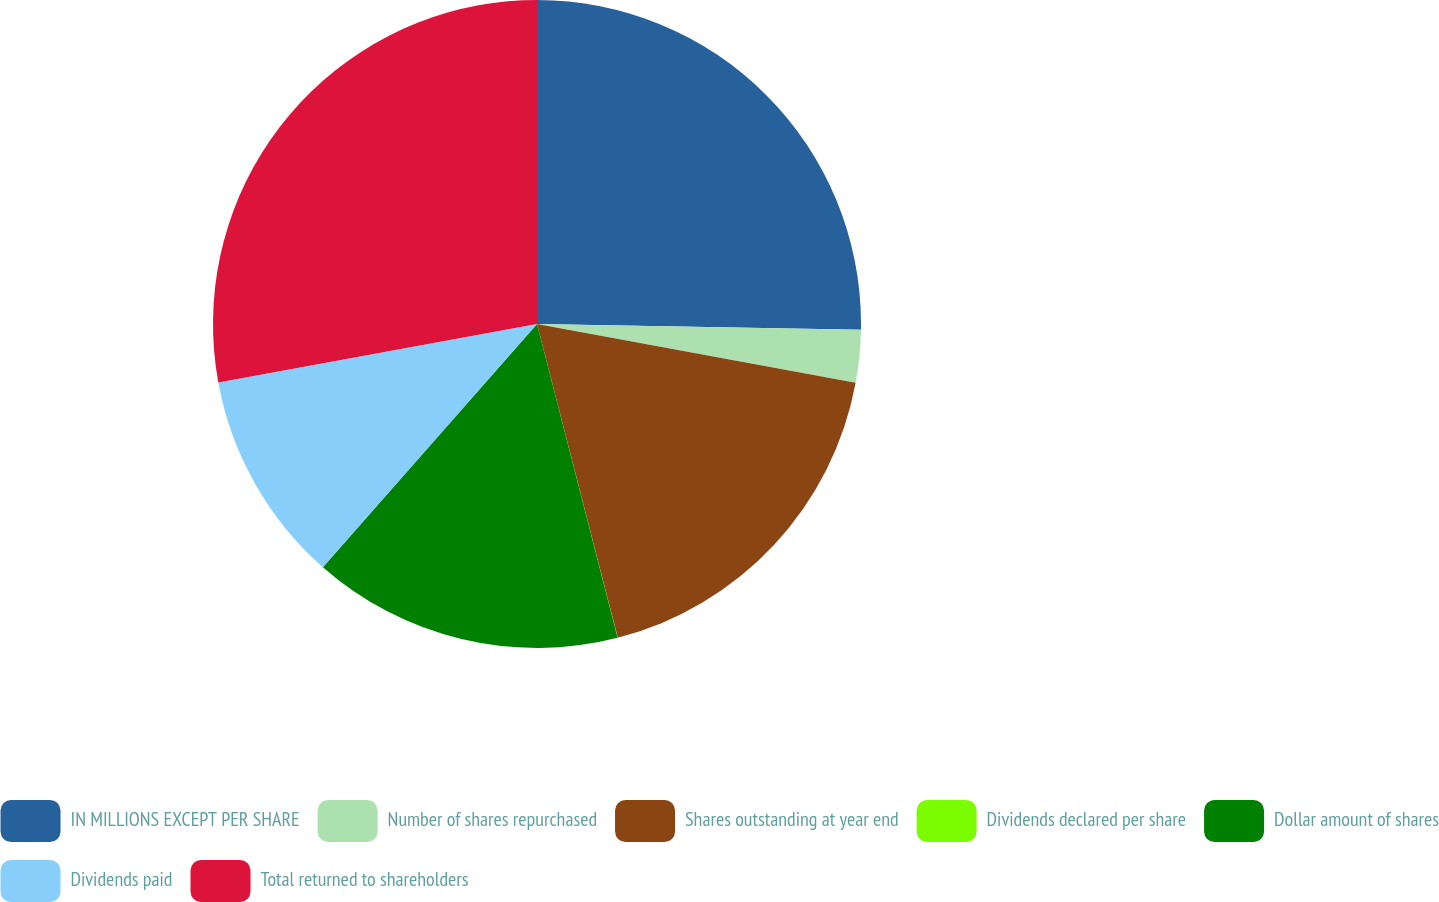<chart> <loc_0><loc_0><loc_500><loc_500><pie_chart><fcel>IN MILLIONS EXCEPT PER SHARE<fcel>Number of shares repurchased<fcel>Shares outstanding at year end<fcel>Dividends declared per share<fcel>Dollar amount of shares<fcel>Dividends paid<fcel>Total returned to shareholders<nl><fcel>25.28%<fcel>2.62%<fcel>18.09%<fcel>0.01%<fcel>15.49%<fcel>10.62%<fcel>27.89%<nl></chart> 